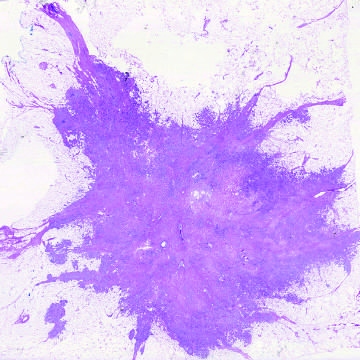what illustrates the invasion of breast stroma and fat by nests and cords of tumor cells?
Answer the question using a single word or phrase. The microscopic view of breast carcinoma 